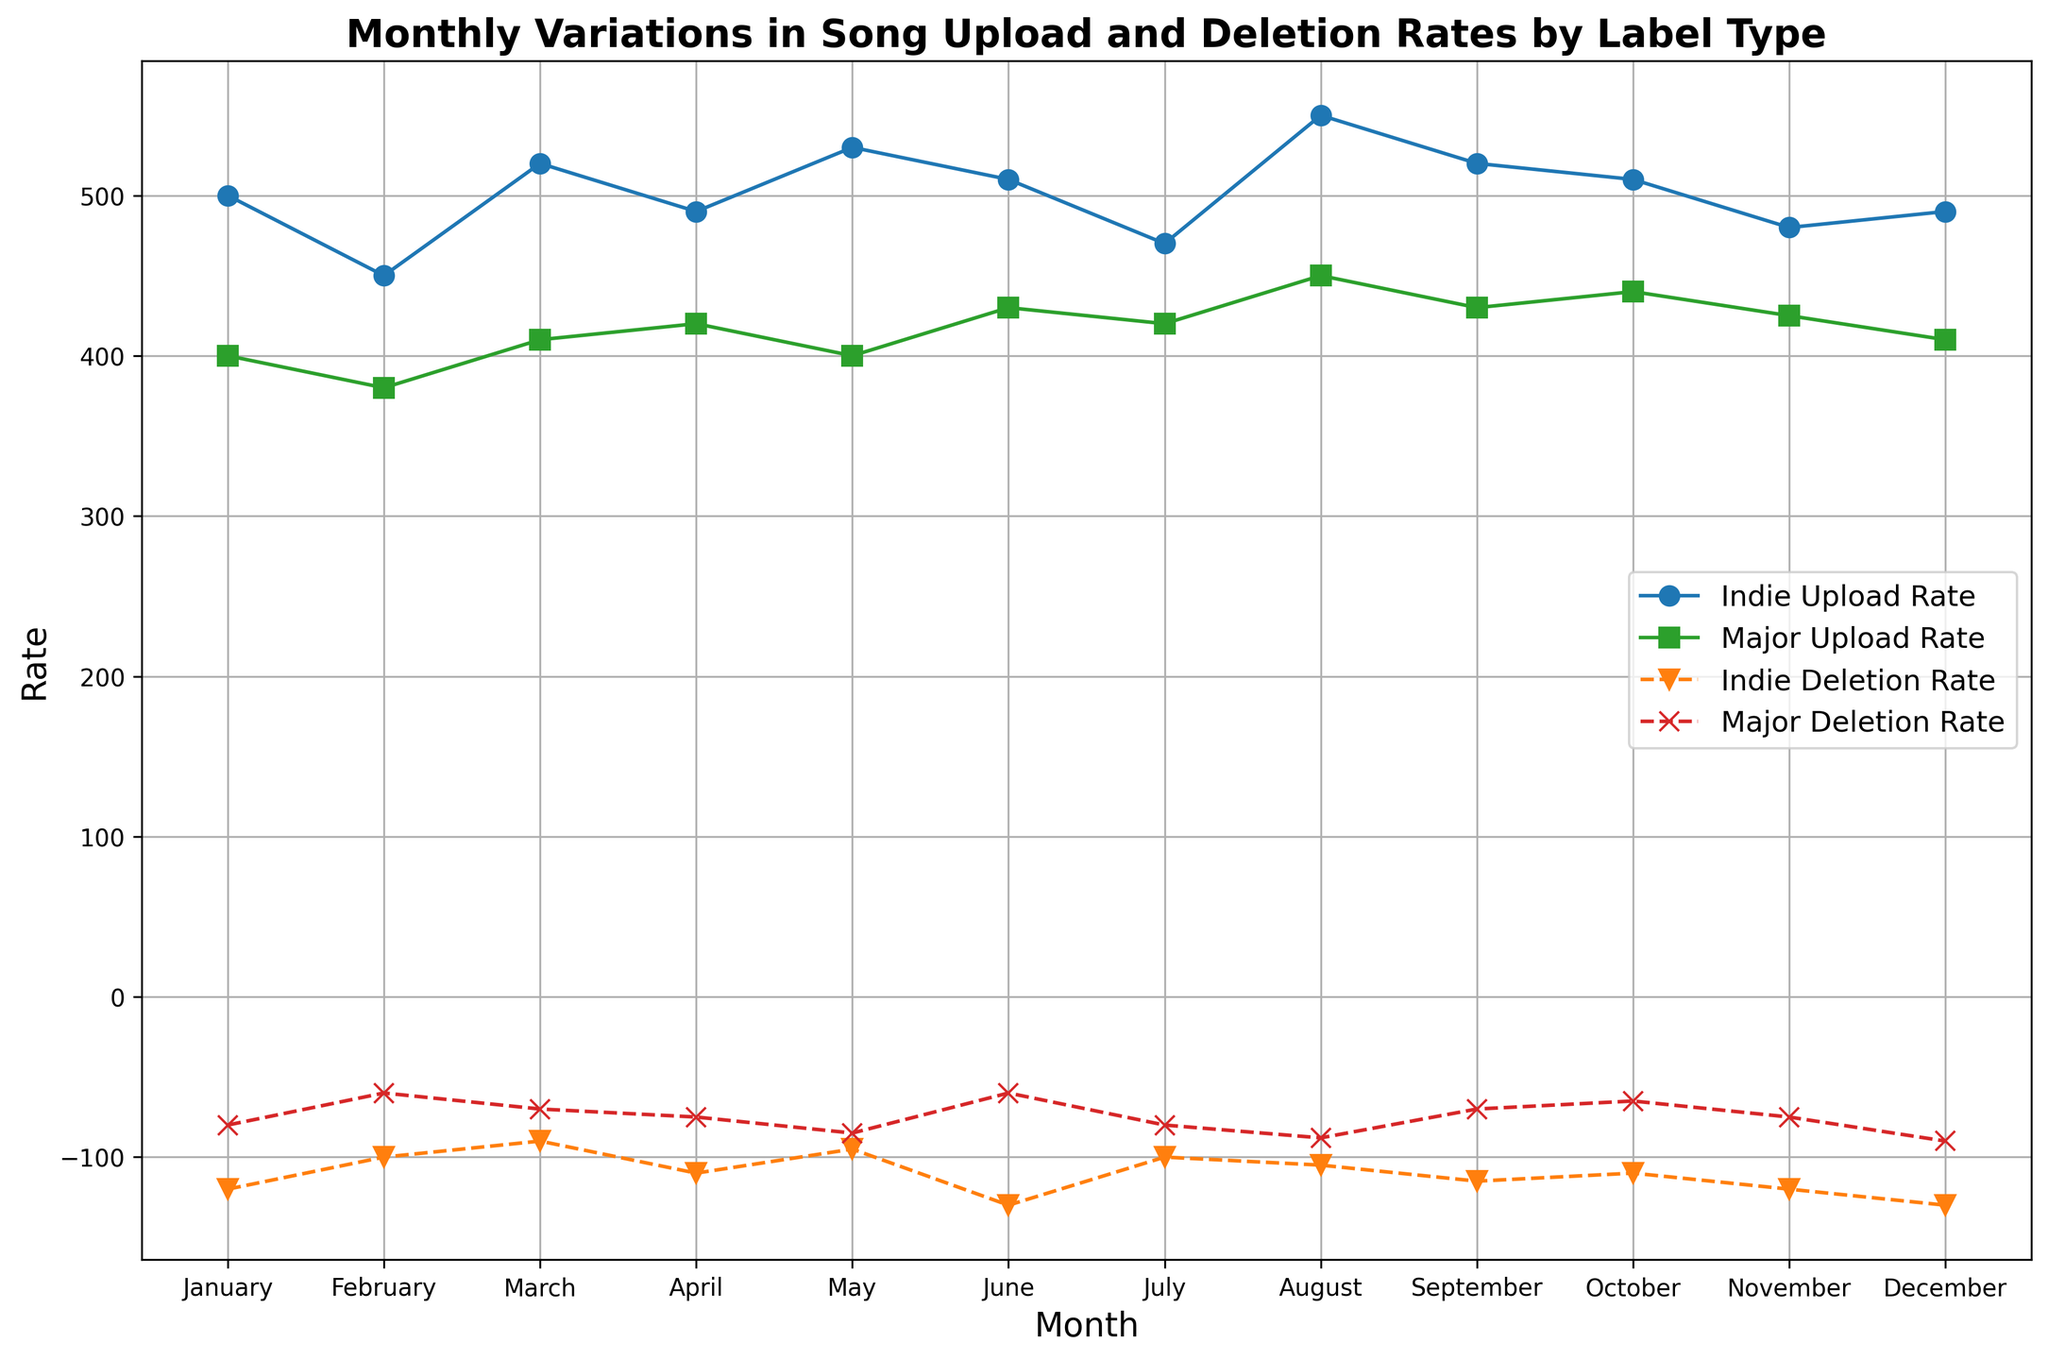What is the highest upload rate for Independent labels? Look for the peak of the blue line representing Independent Upload Rate. It occurs in August at 550.
Answer: 550 Which month shows the lowest deletion rate for Major labels? Identify the lowest point on the red dashed line representing Major Deletion Rate. It occurs in February at -60.
Answer: February Are the upload rates for Major and Independent labels ever equal? Compare the green line (Major Upload Rate) and the blue line (Independent Upload Rate) across all months. They are never equal.
Answer: No In which month is the difference between the upload rates of Independent and Major labels the greatest? Subtract Major Upload Rate from Independent Upload Rate for each month and find the maximum value. The greatest difference occurs in August (550 - 450 = 100).
Answer: August What is the average deletion rate for Independent labels over the year? Sum all the deletion rates for Independent labels and divide by 12. Summing gives (-120 -100 -90 -110 -95 -130 -100 -105 -115 -110 -120 -130 = -1325), so the average is -1325/12 ≈ -110.42.
Answer: -110.42 Which label type had a higher upload rate in November? Compare the points for November on both the blue line (Independent Upload Rate) and the green line (Major Upload Rate). Independent is 480, while Major is 425. Independent is higher.
Answer: Independent During which month do Independent labels and Major labels have the closest deletion rates? Look for the smallest vertical difference between the orange and red dashed lines; it's in May (-95 vs. -85), with a difference of only 10.
Answer: May What is the combined upload rate for both label types in June? Add the upload rates for June from both the blue (Independent) and green (Major) lines. The sum is (510 + 430 = 940).
Answer: 940 Is there any month where the deletion rates for both label types are increasing compared to the previous month? Check the orange (Independent Deletion Rate) and red (Major Deletion Rate) dashed lines for consecutive increases. In December, both deletion rates are higher than in November (Independent: -120 to -130, Major: -75 to -90).
Answer: Yes, in December What is the sum of the highest upload rates for both Independent and Major labels? Identify the highest points on both the blue (Independent) and green (Major) lines. For Independent, it is 550 in August, and for Major, it is 450 in August. The sum is (550 + 450 = 1000).
Answer: 1000 